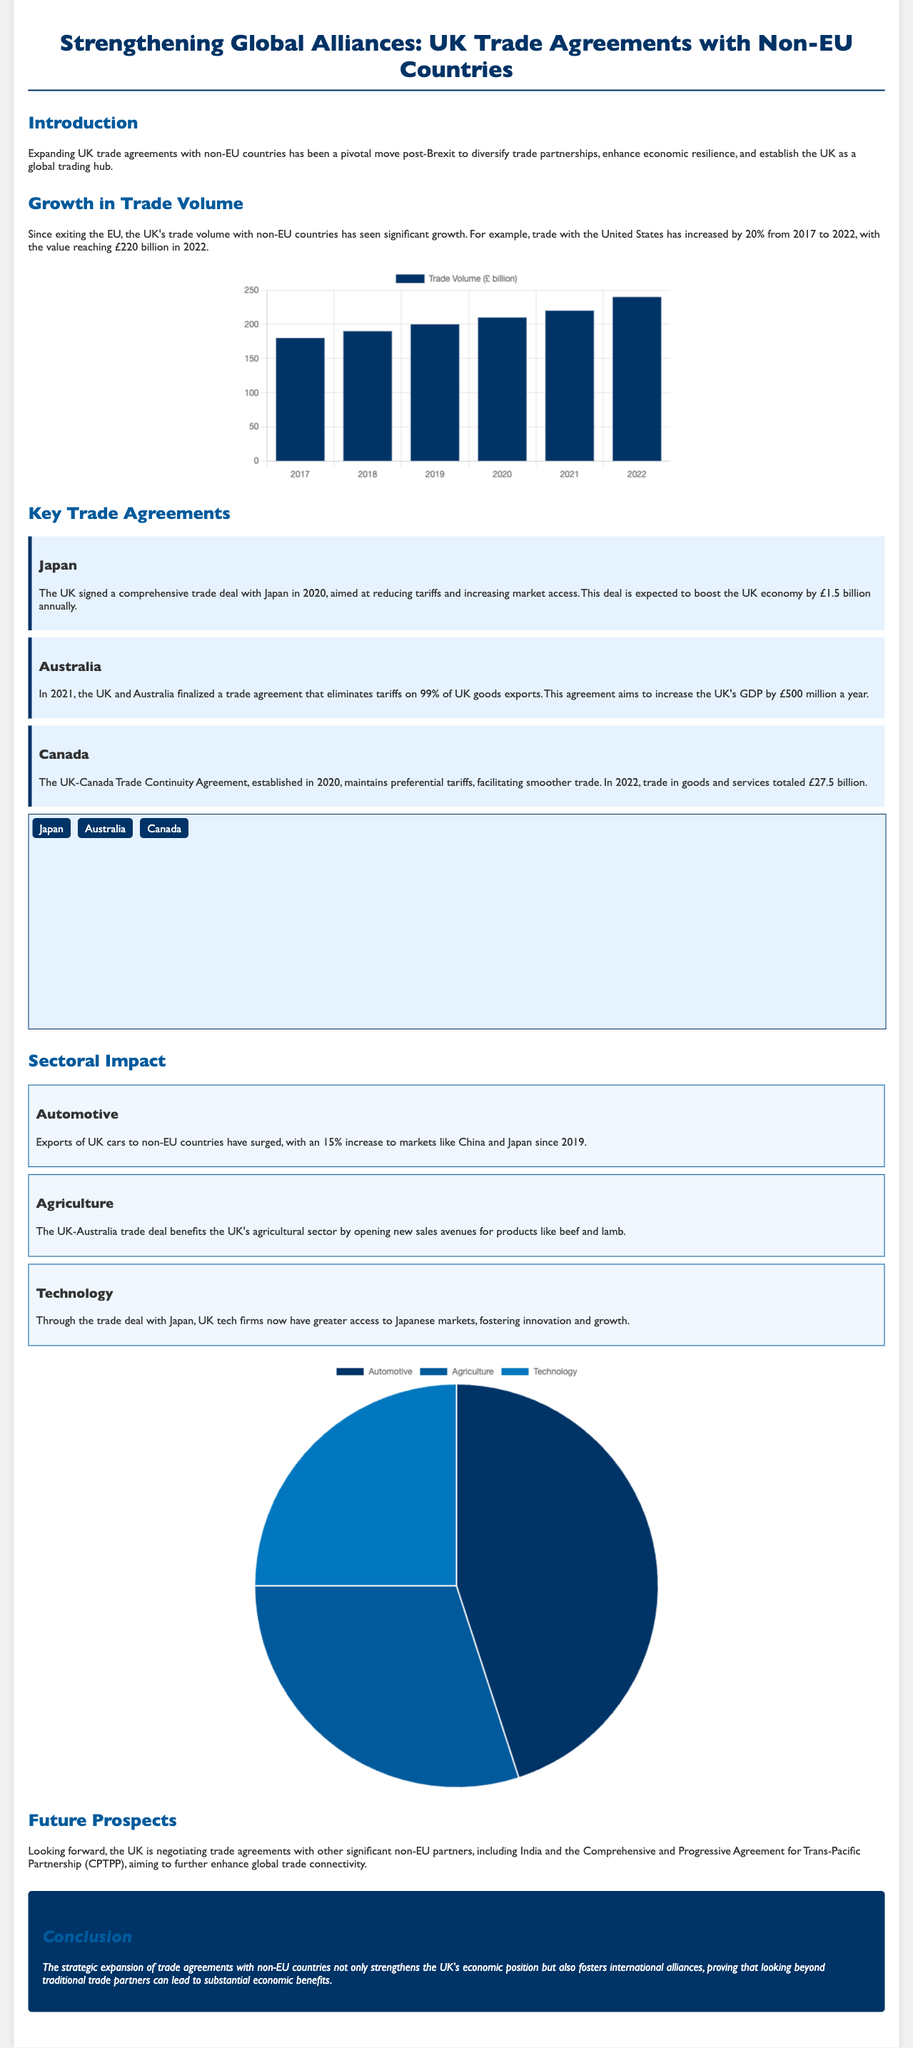What was the trade volume with the United States in 2022? The trade volume with the United States reached £220 billion in 2022.
Answer: £220 billion What is the expected annual boost to the UK economy from the Japan trade deal? The Japan trade deal is expected to boost the UK economy by £1.5 billion annually.
Answer: £1.5 billion Which non-EU country is the UK negotiating a trade agreement with? The UK is negotiating trade agreements with India among other partners.
Answer: India What percentage increase in UK car exports to non-EU countries has occurred since 2019? Exports of UK cars to non-EU countries have surged with a 15% increase since 2019.
Answer: 15% What year was the trade agreement with Australia finalized? The UK and Australia finalized their trade agreement in 2021.
Answer: 2021 How much was the total trade in goods and services with Canada in 2022? In 2022, trade in goods and services with Canada totaled £27.5 billion.
Answer: £27.5 billion What type of chart illustrates the growth in trade volume? A bar chart illustrates the growth in trade volume in the document.
Answer: Bar chart What background color is used for the trade agreements section? The background color for the trade agreements section is #e6f3ff.
Answer: #e6f3ff What is the primary focus of the infographics document? The primary focus of the document is on strengthening global alliances through trade agreements with non-EU countries.
Answer: Strengthening global alliances 